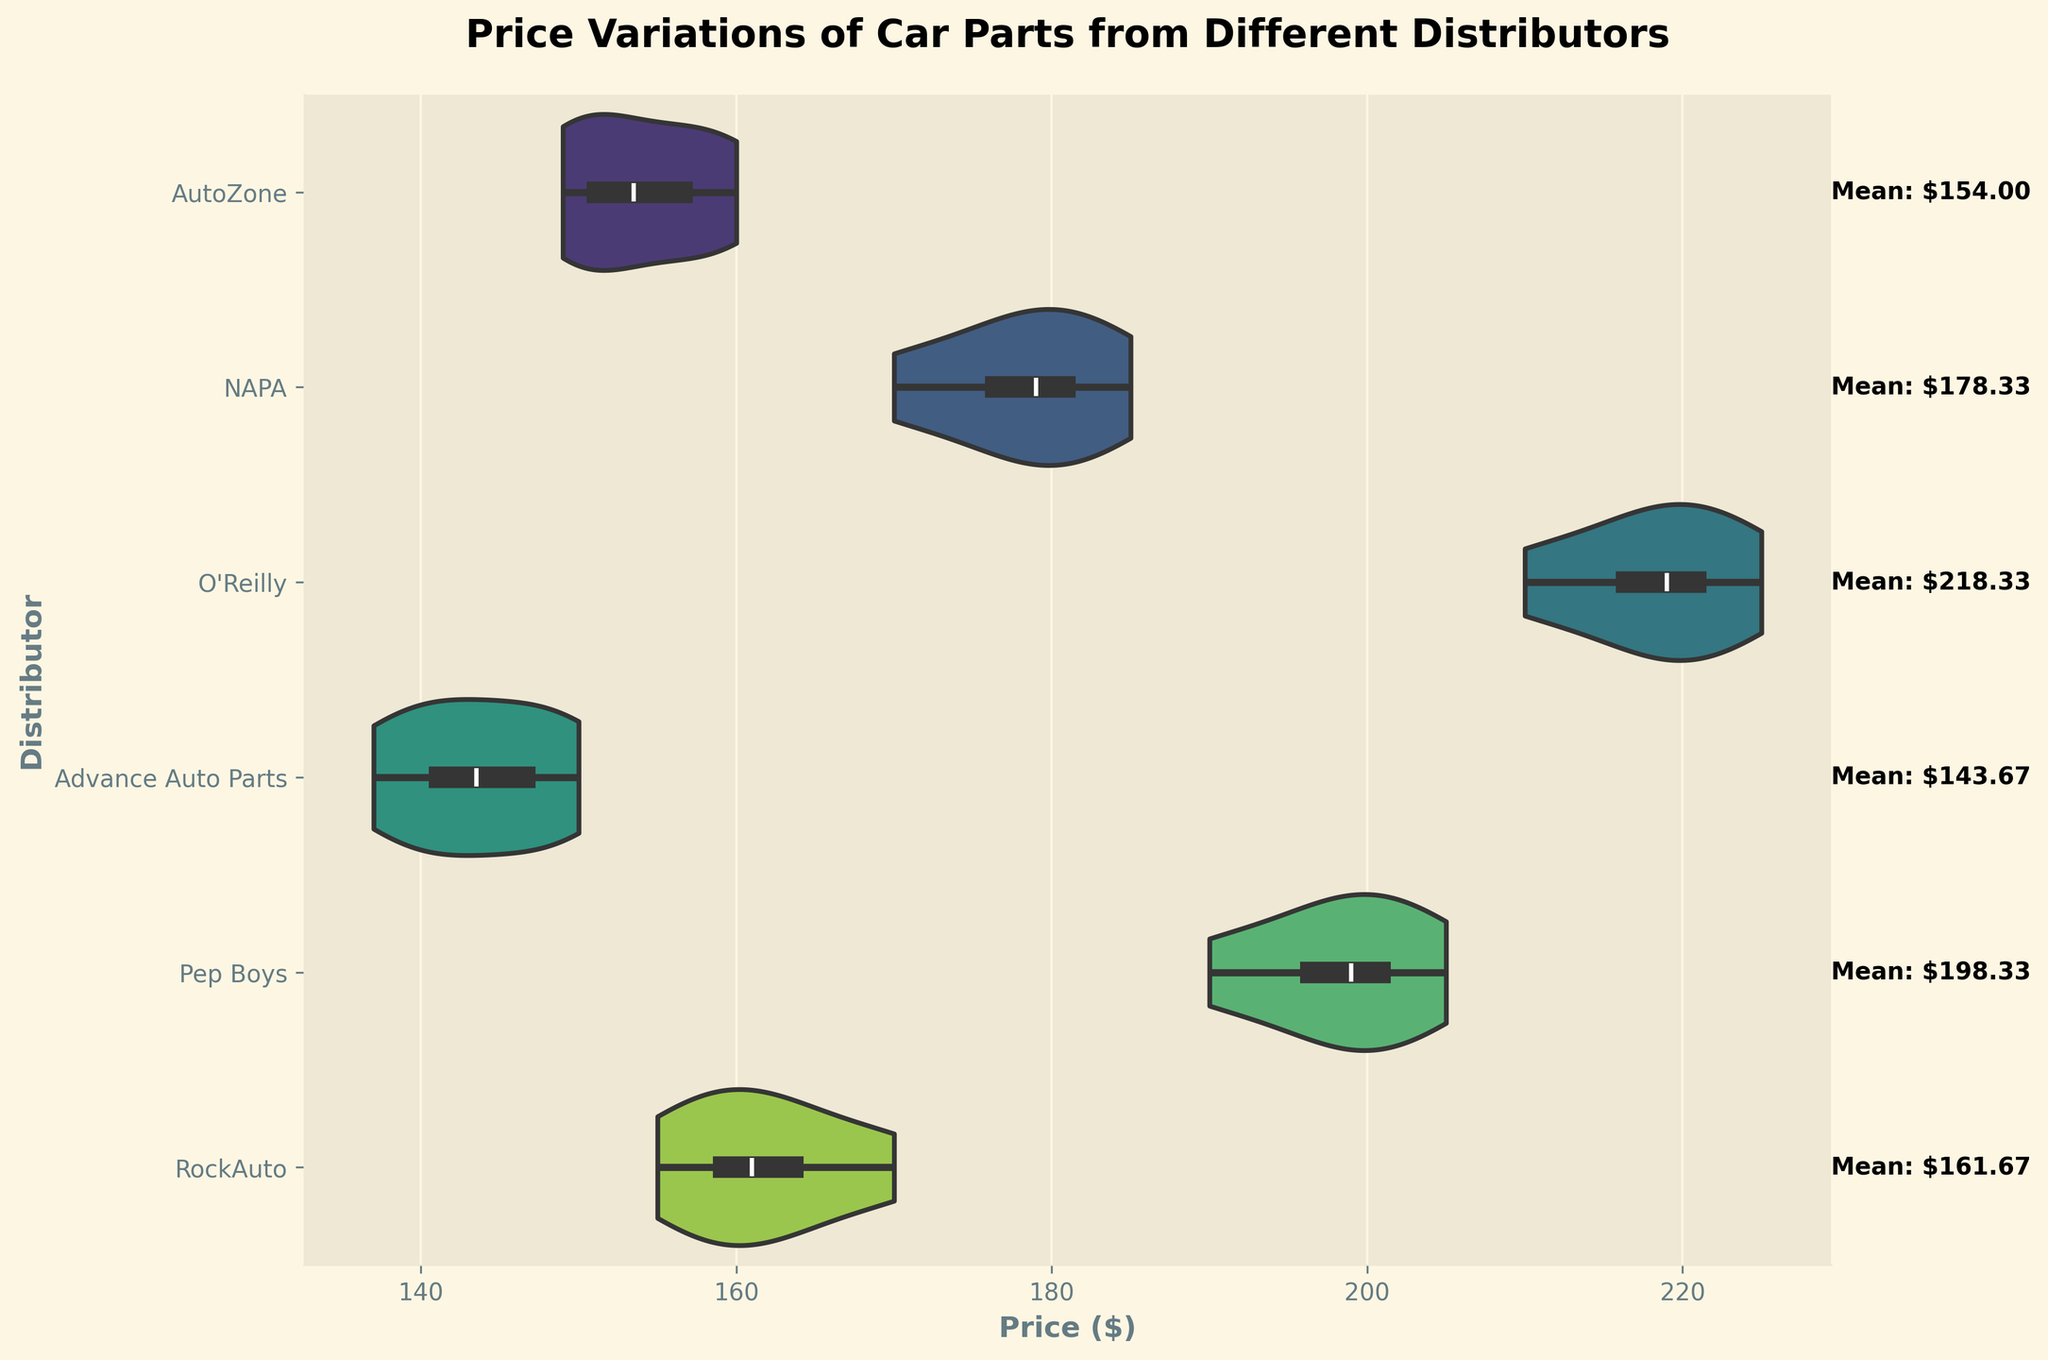Which distributor has the highest mean price displayed on the figure? The figure shows each distributor's mean price indicated by text next to their violin plot. By comparing these labeled values, O'Reilly has the highest mean price.
Answer: O'Reilly What is the price range (difference between maximum and minimum prices) for Advance Auto Parts? The violin plot indicates the spread of prices for each distributor. Observing the ends of the Advance Auto Parts plot, prices range from around $137 to $150. Therefore, the range is 150 - 137 = 13.
Answer: 13 How do the price variations of AutoZone compare with those of NAPA? By examining the shape and spread of the violin plots, AutoZone’s prices are more centrally concentrated with a narrower range, while NAPA shows a wider spread of prices, indicating more variation.
Answer: NAPA has more variations Which distributor has the smallest median price? The median is indicated by the center of the 'inner' box in the violin plot. By comparing medians, Advance Auto Parts has the lowest median price.
Answer: Advance Auto Parts Are the price variations for RockAuto positively or negatively skewed? The violin plot's shape for RockAuto shows a tail extending more toward higher prices, indicating it is positively skewed.
Answer: Positively skewed Is there a distributor whose prices are more consistent (less variance) compared to others? By examining the tightness of the violin plot, AutoZone shows a relatively narrow spread, indicating more consistent prices.
Answer: AutoZone What is the average price of NAPA's car parts as displayed on the figure? The figure displays the average price for each distributor next to their plot. For NAPA, it is approximately $178.33.
Answer: $178.33 Which distributor has prices with the greatest interquartile range? The interquartile range is represented by the width of the 'inner' box. Comparing the widths across distributors, O'Reilly’s prices have the greatest interquartile range.
Answer: O'Reilly 